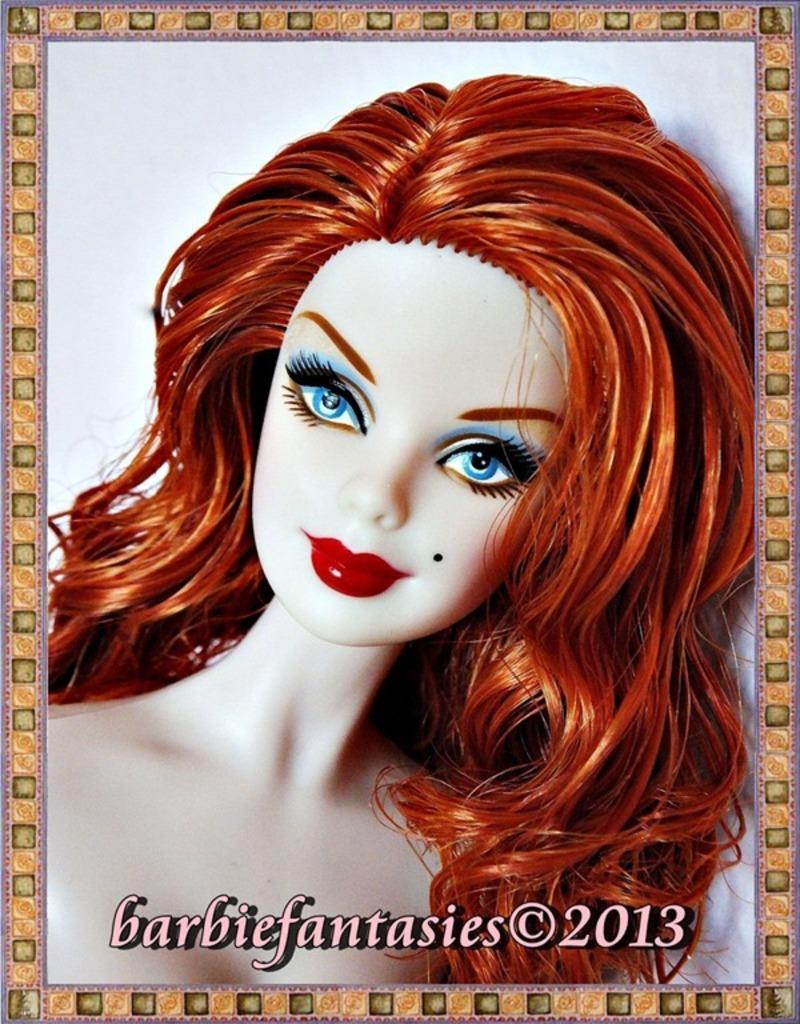How would you summarize this image in a sentence or two? In the picture I can see the painting photo frame of a woman. 